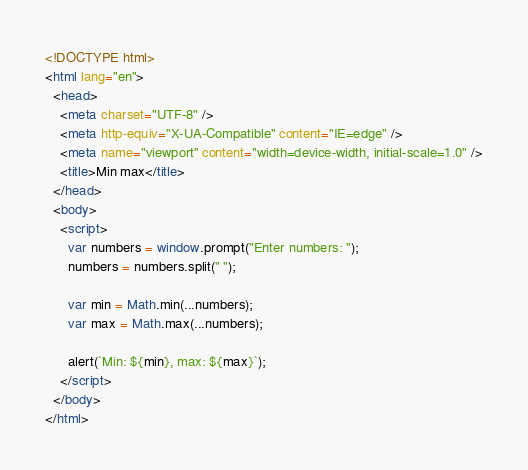<code> <loc_0><loc_0><loc_500><loc_500><_HTML_><!DOCTYPE html>
<html lang="en">
  <head>
    <meta charset="UTF-8" />
    <meta http-equiv="X-UA-Compatible" content="IE=edge" />
    <meta name="viewport" content="width=device-width, initial-scale=1.0" />
    <title>Min max</title>
  </head>
  <body>
    <script>
      var numbers = window.prompt("Enter numbers: ");
      numbers = numbers.split(" ");

      var min = Math.min(...numbers);
      var max = Math.max(...numbers);

      alert(`Min: ${min}, max: ${max}`);
    </script>
  </body>
</html>
</code> 